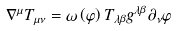<formula> <loc_0><loc_0><loc_500><loc_500>\nabla ^ { \mu } T _ { \mu \nu } = \omega \left ( \varphi \right ) T _ { \lambda \beta } g ^ { \lambda \beta } \partial _ { \nu } \varphi</formula> 